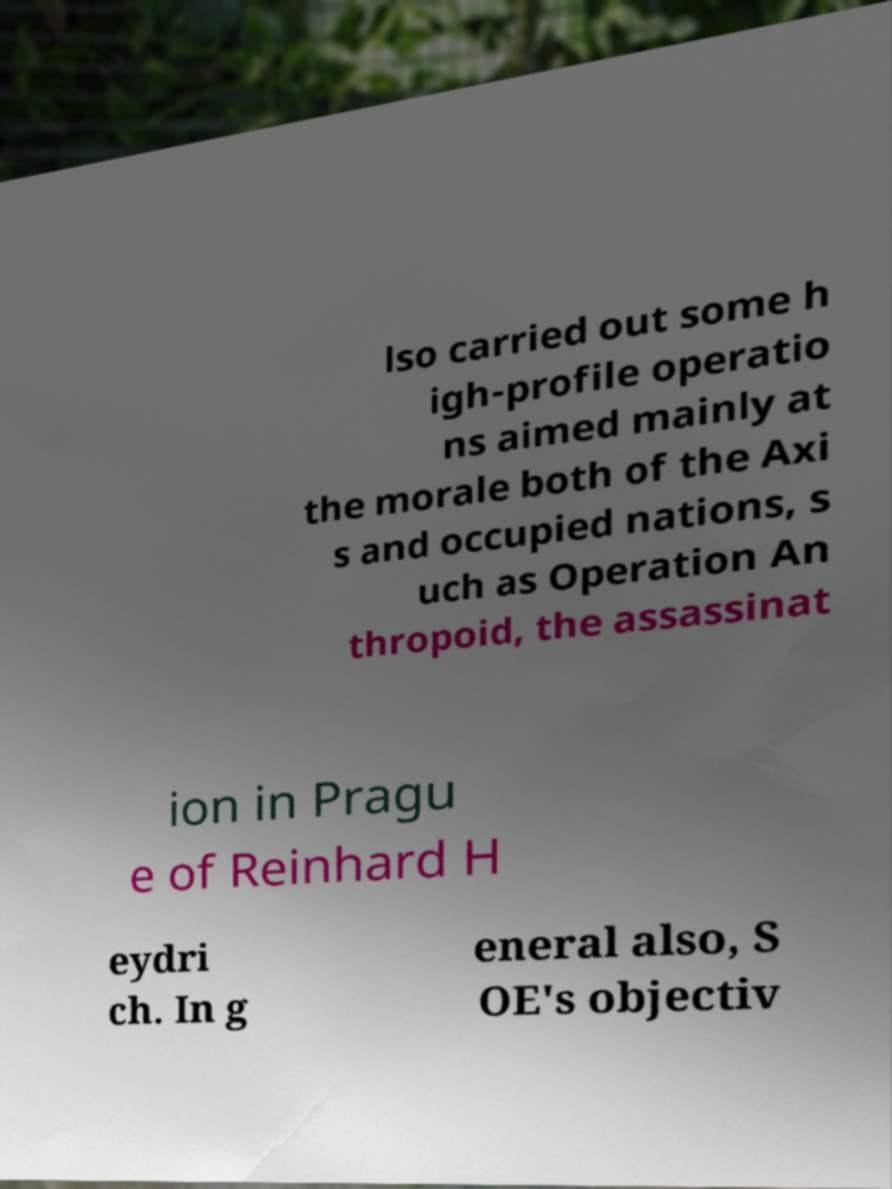Can you accurately transcribe the text from the provided image for me? lso carried out some h igh-profile operatio ns aimed mainly at the morale both of the Axi s and occupied nations, s uch as Operation An thropoid, the assassinat ion in Pragu e of Reinhard H eydri ch. In g eneral also, S OE's objectiv 